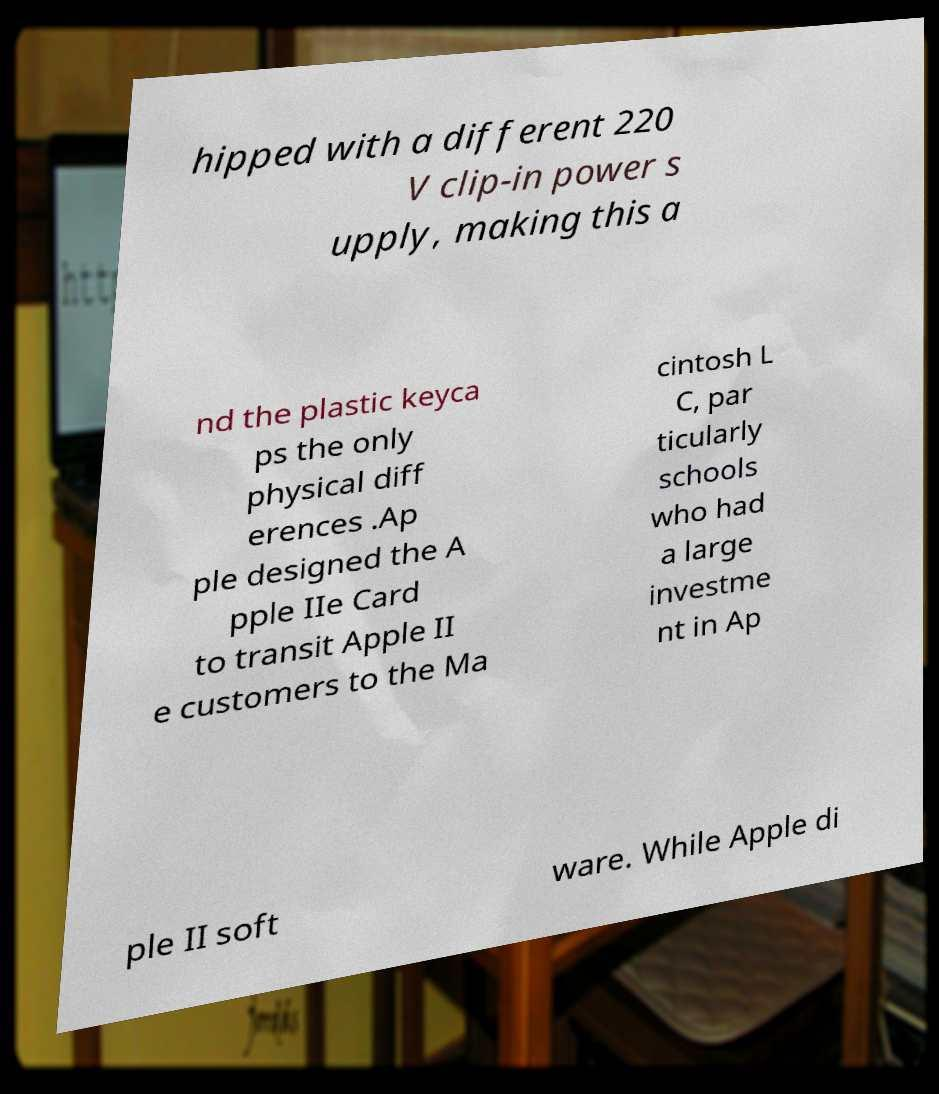Could you extract and type out the text from this image? hipped with a different 220 V clip-in power s upply, making this a nd the plastic keyca ps the only physical diff erences .Ap ple designed the A pple IIe Card to transit Apple II e customers to the Ma cintosh L C, par ticularly schools who had a large investme nt in Ap ple II soft ware. While Apple di 